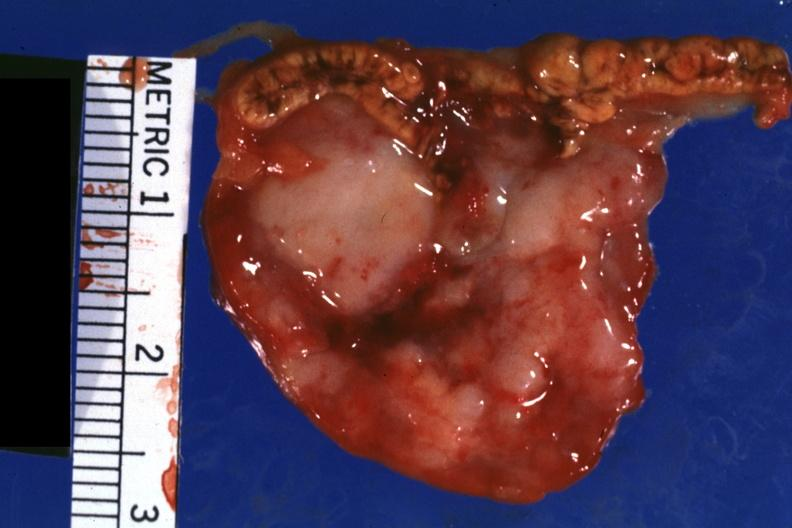what is present?
Answer the question using a single word or phrase. Endocrine 